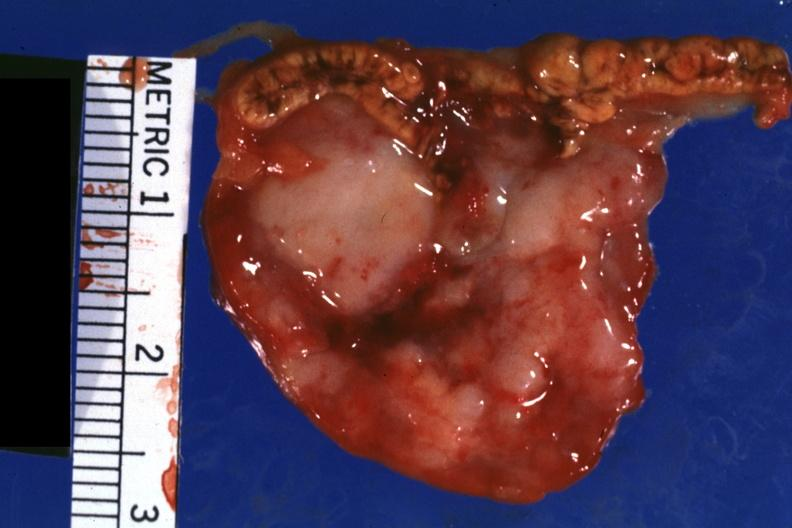what is present?
Answer the question using a single word or phrase. Endocrine 